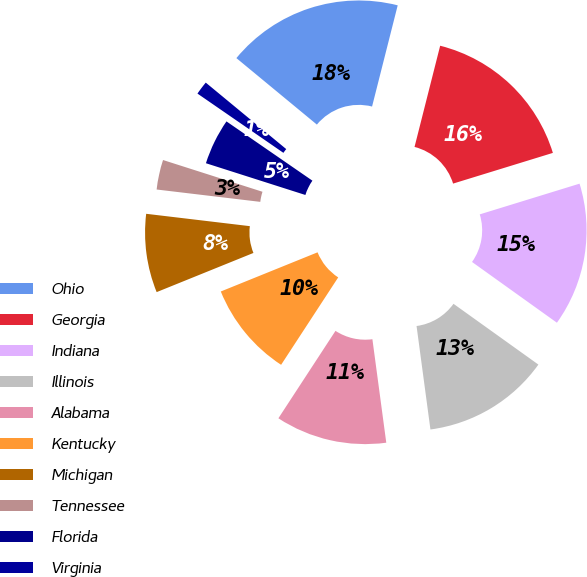Convert chart. <chart><loc_0><loc_0><loc_500><loc_500><pie_chart><fcel>Ohio<fcel>Georgia<fcel>Indiana<fcel>Illinois<fcel>Alabama<fcel>Kentucky<fcel>Michigan<fcel>Tennessee<fcel>Florida<fcel>Virginia<nl><fcel>17.96%<fcel>16.3%<fcel>14.64%<fcel>12.99%<fcel>11.33%<fcel>9.67%<fcel>8.01%<fcel>3.03%<fcel>4.69%<fcel>1.38%<nl></chart> 